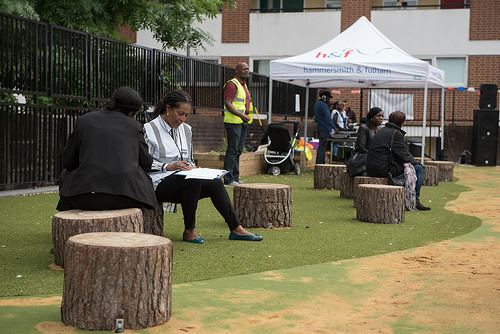<image>
Is the man under the roof? No. The man is not positioned under the roof. The vertical relationship between these objects is different. 